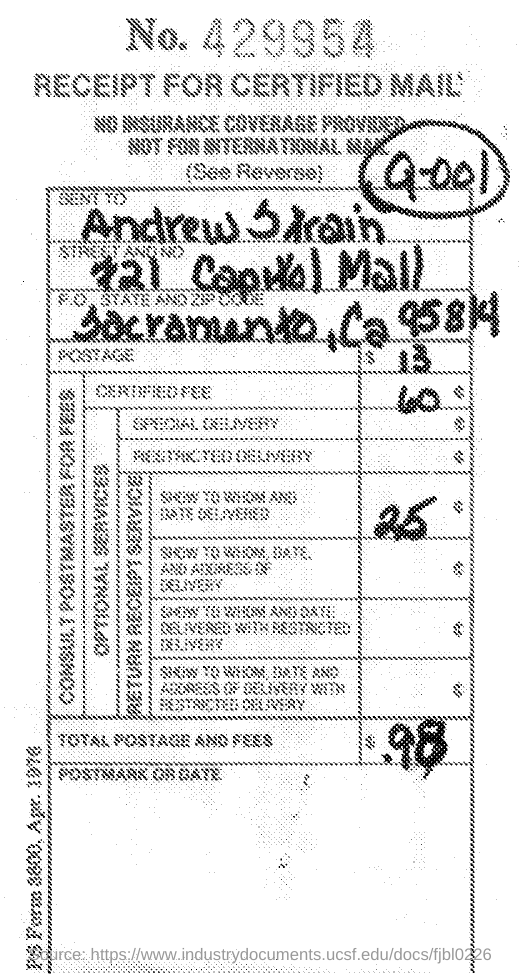Highlight a few significant elements in this photo. The total postage and fees is $0.98. 